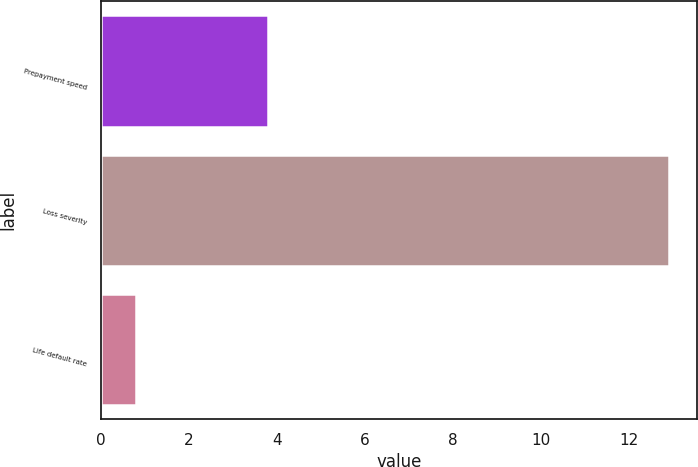Convert chart to OTSL. <chart><loc_0><loc_0><loc_500><loc_500><bar_chart><fcel>Prepayment speed<fcel>Loss severity<fcel>Life default rate<nl><fcel>3.8<fcel>12.9<fcel>0.8<nl></chart> 